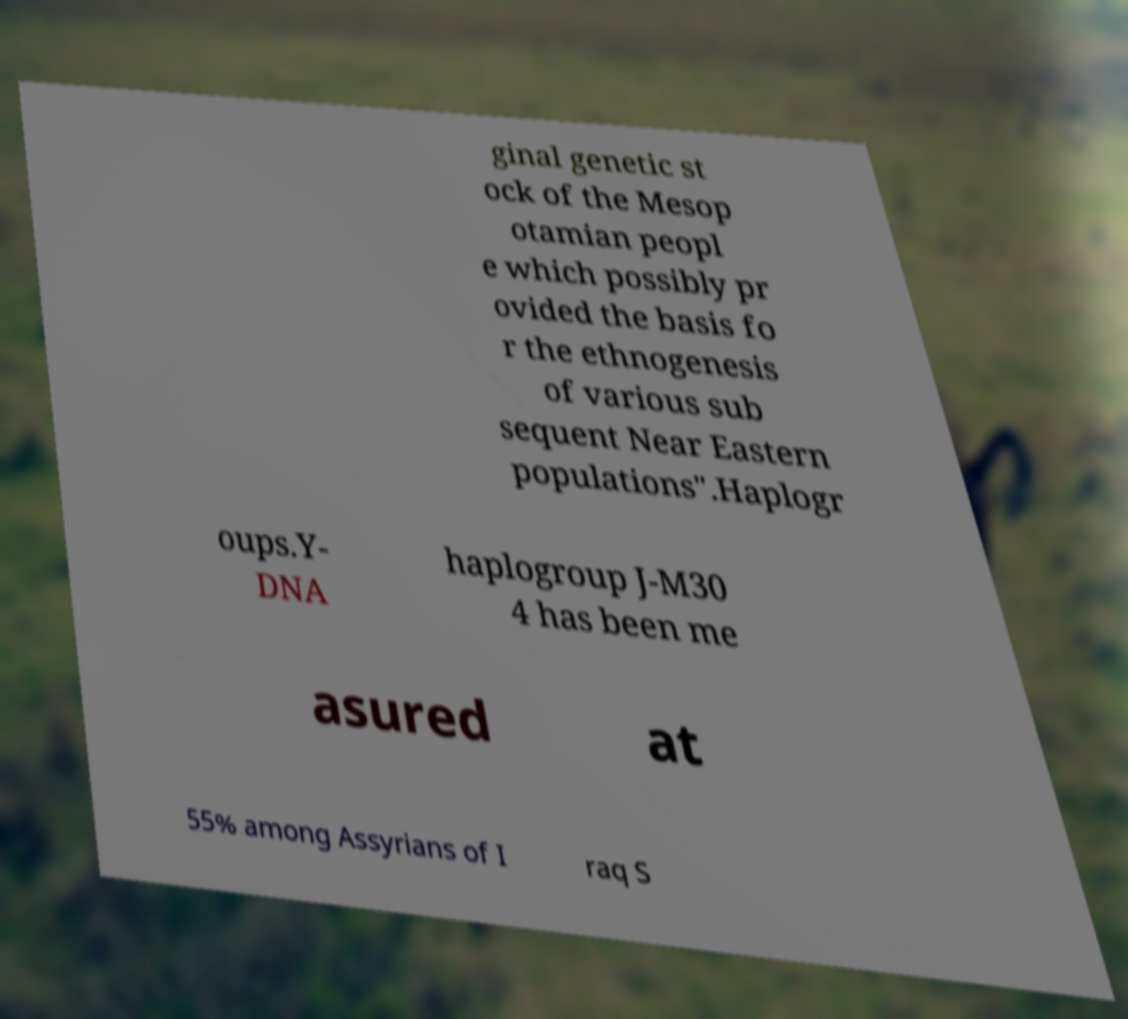Can you read and provide the text displayed in the image?This photo seems to have some interesting text. Can you extract and type it out for me? ginal genetic st ock of the Mesop otamian peopl e which possibly pr ovided the basis fo r the ethnogenesis of various sub sequent Near Eastern populations".Haplogr oups.Y- DNA haplogroup J-M30 4 has been me asured at 55% among Assyrians of I raq S 